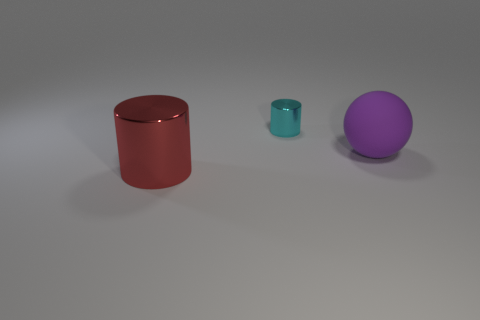Is there any other thing that is made of the same material as the big purple ball?
Give a very brief answer. No. How big is the thing that is both in front of the tiny cyan thing and left of the big ball?
Keep it short and to the point. Large. Do the shiny thing that is to the left of the small cyan cylinder and the purple rubber thing have the same shape?
Provide a short and direct response. No. There is a metal object to the right of the cylinder that is in front of the sphere that is right of the big red cylinder; what is its size?
Your answer should be very brief. Small. How many objects are either big matte objects or tiny metallic cylinders?
Your answer should be very brief. 2. There is a thing that is in front of the small cyan object and on the left side of the purple object; what is its shape?
Your answer should be very brief. Cylinder. There is a red object; is it the same shape as the metallic thing that is on the right side of the red thing?
Offer a terse response. Yes. There is a red metal cylinder; are there any metal cylinders right of it?
Offer a very short reply. Yes. What number of cylinders are red objects or big purple matte things?
Offer a terse response. 1. Is the shape of the red object the same as the large matte object?
Your response must be concise. No. 